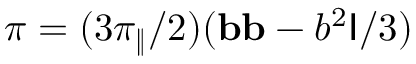Convert formula to latex. <formula><loc_0><loc_0><loc_500><loc_500>\pi = ( 3 \pi _ { \| } / 2 ) ( b b - b ^ { 2 } I / 3 )</formula> 